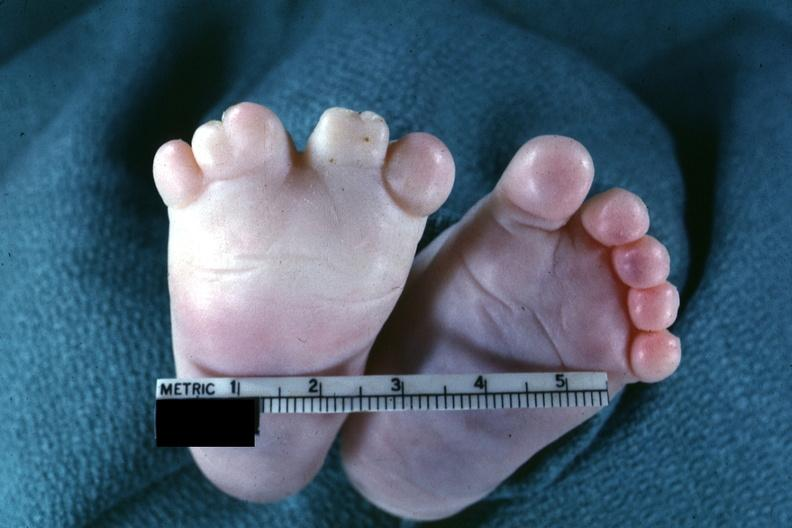what is present?
Answer the question using a single word or phrase. Feet 